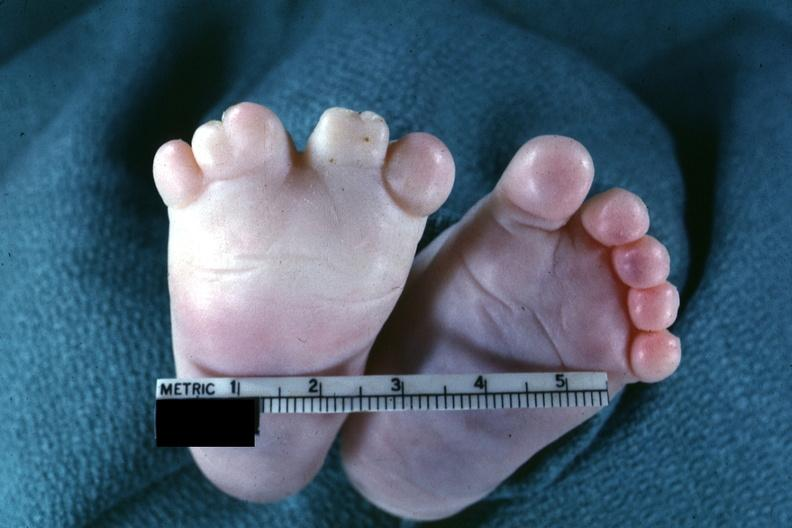what is present?
Answer the question using a single word or phrase. Feet 